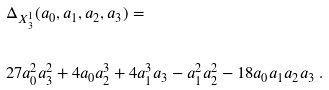Convert formula to latex. <formula><loc_0><loc_0><loc_500><loc_500>& \Delta _ { X ^ { 1 } _ { 3 } } ( a _ { 0 } , a _ { 1 } , a _ { 2 } , a _ { 3 } ) = \\ \ \\ & 2 7 a _ { 0 } ^ { 2 } a _ { 3 } ^ { 2 } + 4 a _ { 0 } a _ { 2 } ^ { 3 } + 4 a _ { 1 } ^ { 3 } a _ { 3 } - a _ { 1 } ^ { 2 } a _ { 2 } ^ { 2 } - 1 8 a _ { 0 } a _ { 1 } a _ { 2 } a _ { 3 } \ .</formula> 